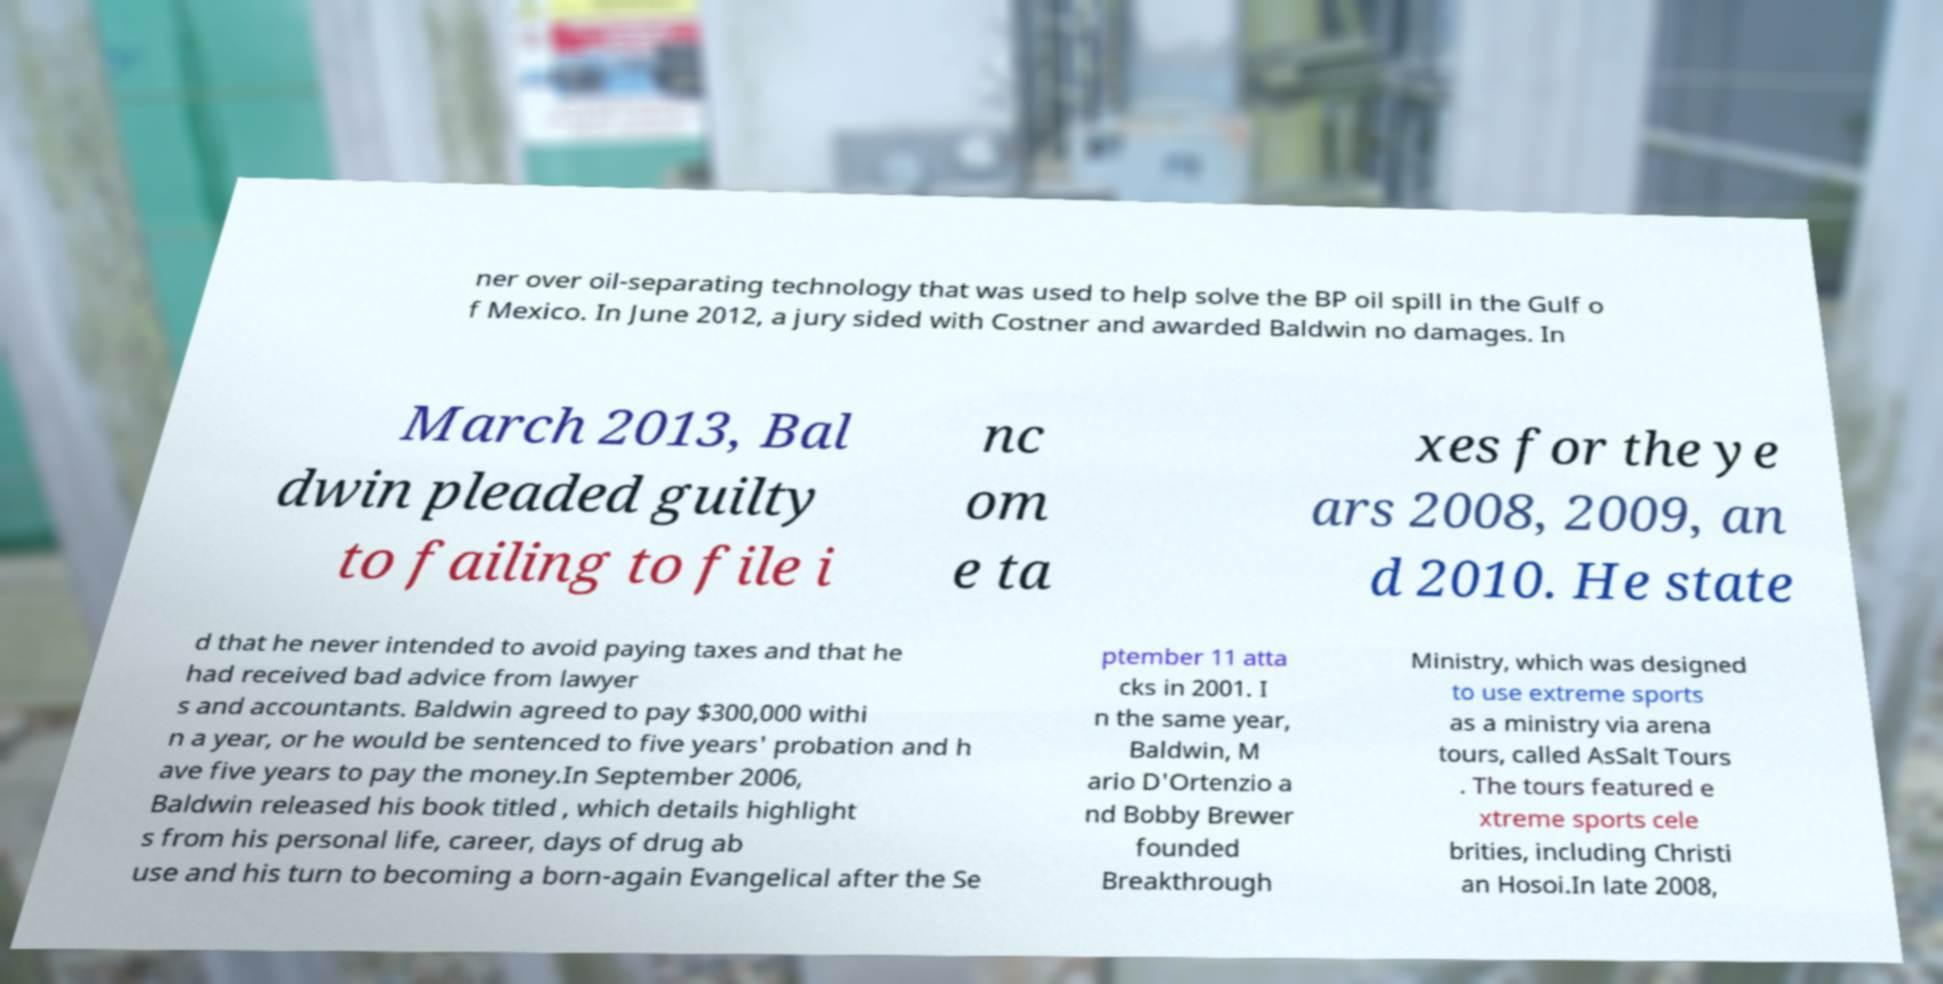What messages or text are displayed in this image? I need them in a readable, typed format. ner over oil-separating technology that was used to help solve the BP oil spill in the Gulf o f Mexico. In June 2012, a jury sided with Costner and awarded Baldwin no damages. In March 2013, Bal dwin pleaded guilty to failing to file i nc om e ta xes for the ye ars 2008, 2009, an d 2010. He state d that he never intended to avoid paying taxes and that he had received bad advice from lawyer s and accountants. Baldwin agreed to pay $300,000 withi n a year, or he would be sentenced to five years' probation and h ave five years to pay the money.In September 2006, Baldwin released his book titled , which details highlight s from his personal life, career, days of drug ab use and his turn to becoming a born-again Evangelical after the Se ptember 11 atta cks in 2001. I n the same year, Baldwin, M ario D'Ortenzio a nd Bobby Brewer founded Breakthrough Ministry, which was designed to use extreme sports as a ministry via arena tours, called AsSalt Tours . The tours featured e xtreme sports cele brities, including Christi an Hosoi.In late 2008, 